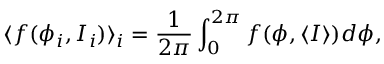<formula> <loc_0><loc_0><loc_500><loc_500>\langle f ( \phi _ { i } , I _ { i } ) \rangle _ { i } = \frac { 1 } { 2 \pi } \int _ { 0 } ^ { 2 \pi } f ( \phi , \langle I \rangle ) d \phi ,</formula> 